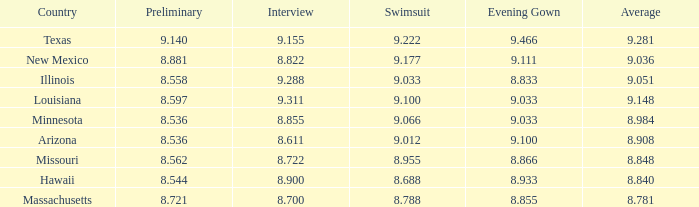Would you mind parsing the complete table? {'header': ['Country', 'Preliminary', 'Interview', 'Swimsuit', 'Evening Gown', 'Average'], 'rows': [['Texas', '9.140', '9.155', '9.222', '9.466', '9.281'], ['New Mexico', '8.881', '8.822', '9.177', '9.111', '9.036'], ['Illinois', '8.558', '9.288', '9.033', '8.833', '9.051'], ['Louisiana', '8.597', '9.311', '9.100', '9.033', '9.148'], ['Minnesota', '8.536', '8.855', '9.066', '9.033', '8.984'], ['Arizona', '8.536', '8.611', '9.012', '9.100', '8.908'], ['Missouri', '8.562', '8.722', '8.955', '8.866', '8.848'], ['Hawaii', '8.544', '8.900', '8.688', '8.933', '8.840'], ['Massachusetts', '8.721', '8.700', '8.788', '8.855', '8.781']]} 848? 8.955. 